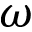Convert formula to latex. <formula><loc_0><loc_0><loc_500><loc_500>\omega</formula> 